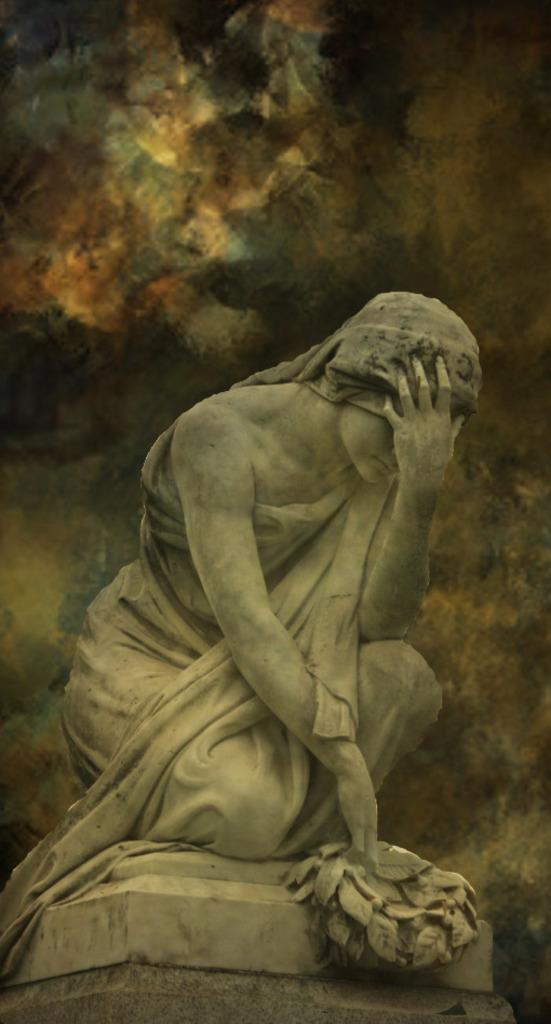What is the main subject in the foreground of the picture? There is a sculpture in the foreground of the picture. Can you describe any changes made to the image? The image has been edited. What can be seen in the background of the picture? There are clouds in the background of the picture. How many fans are visible in the image? There are no fans present in the image. Is there a cactus growing near the sculpture in the image? There is no cactus visible in the image. 